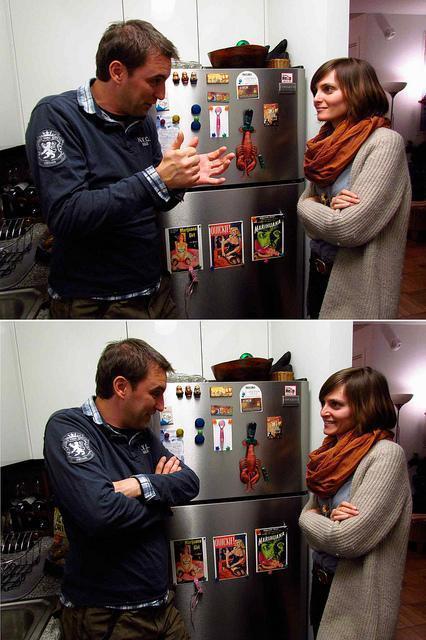How did the women feel about the man's remark?
Choose the correct response and explain in the format: 'Answer: answer
Rationale: rationale.'
Options: Bored, amused, offended, embarrassed. Answer: amused.
Rationale: She is smiling. 